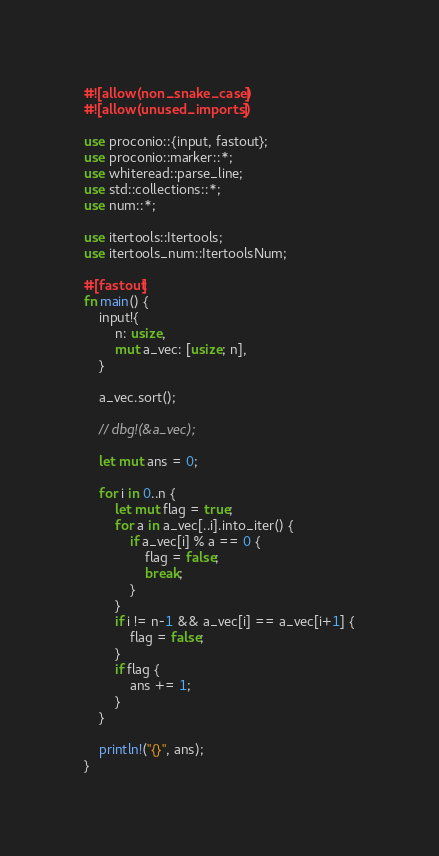<code> <loc_0><loc_0><loc_500><loc_500><_Rust_>#![allow(non_snake_case)]
#![allow(unused_imports)]

use proconio::{input, fastout};
use proconio::marker::*;
use whiteread::parse_line;
use std::collections::*;
use num::*;

use itertools::Itertools;
use itertools_num::ItertoolsNum;

#[fastout]
fn main() {
    input!{
        n: usize,
        mut a_vec: [usize; n],
    }

    a_vec.sort();

    // dbg!(&a_vec);

    let mut ans = 0;

    for i in 0..n {
        let mut flag = true;
        for a in a_vec[..i].into_iter() {
            if a_vec[i] % a == 0 {
                flag = false;
                break;
            }
        }
        if i != n-1 && a_vec[i] == a_vec[i+1] {
            flag = false;
        }
        if flag {
            ans += 1;
        }
    }

    println!("{}", ans);
}
</code> 